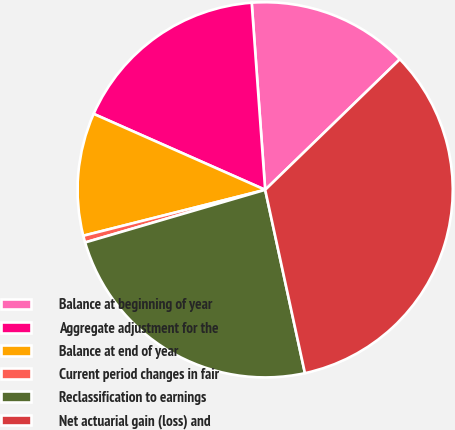Convert chart to OTSL. <chart><loc_0><loc_0><loc_500><loc_500><pie_chart><fcel>Balance at beginning of year<fcel>Aggregate adjustment for the<fcel>Balance at end of year<fcel>Current period changes in fair<fcel>Reclassification to earnings<fcel>Net actuarial gain (loss) and<nl><fcel>13.89%<fcel>17.22%<fcel>10.57%<fcel>0.59%<fcel>23.87%<fcel>33.85%<nl></chart> 